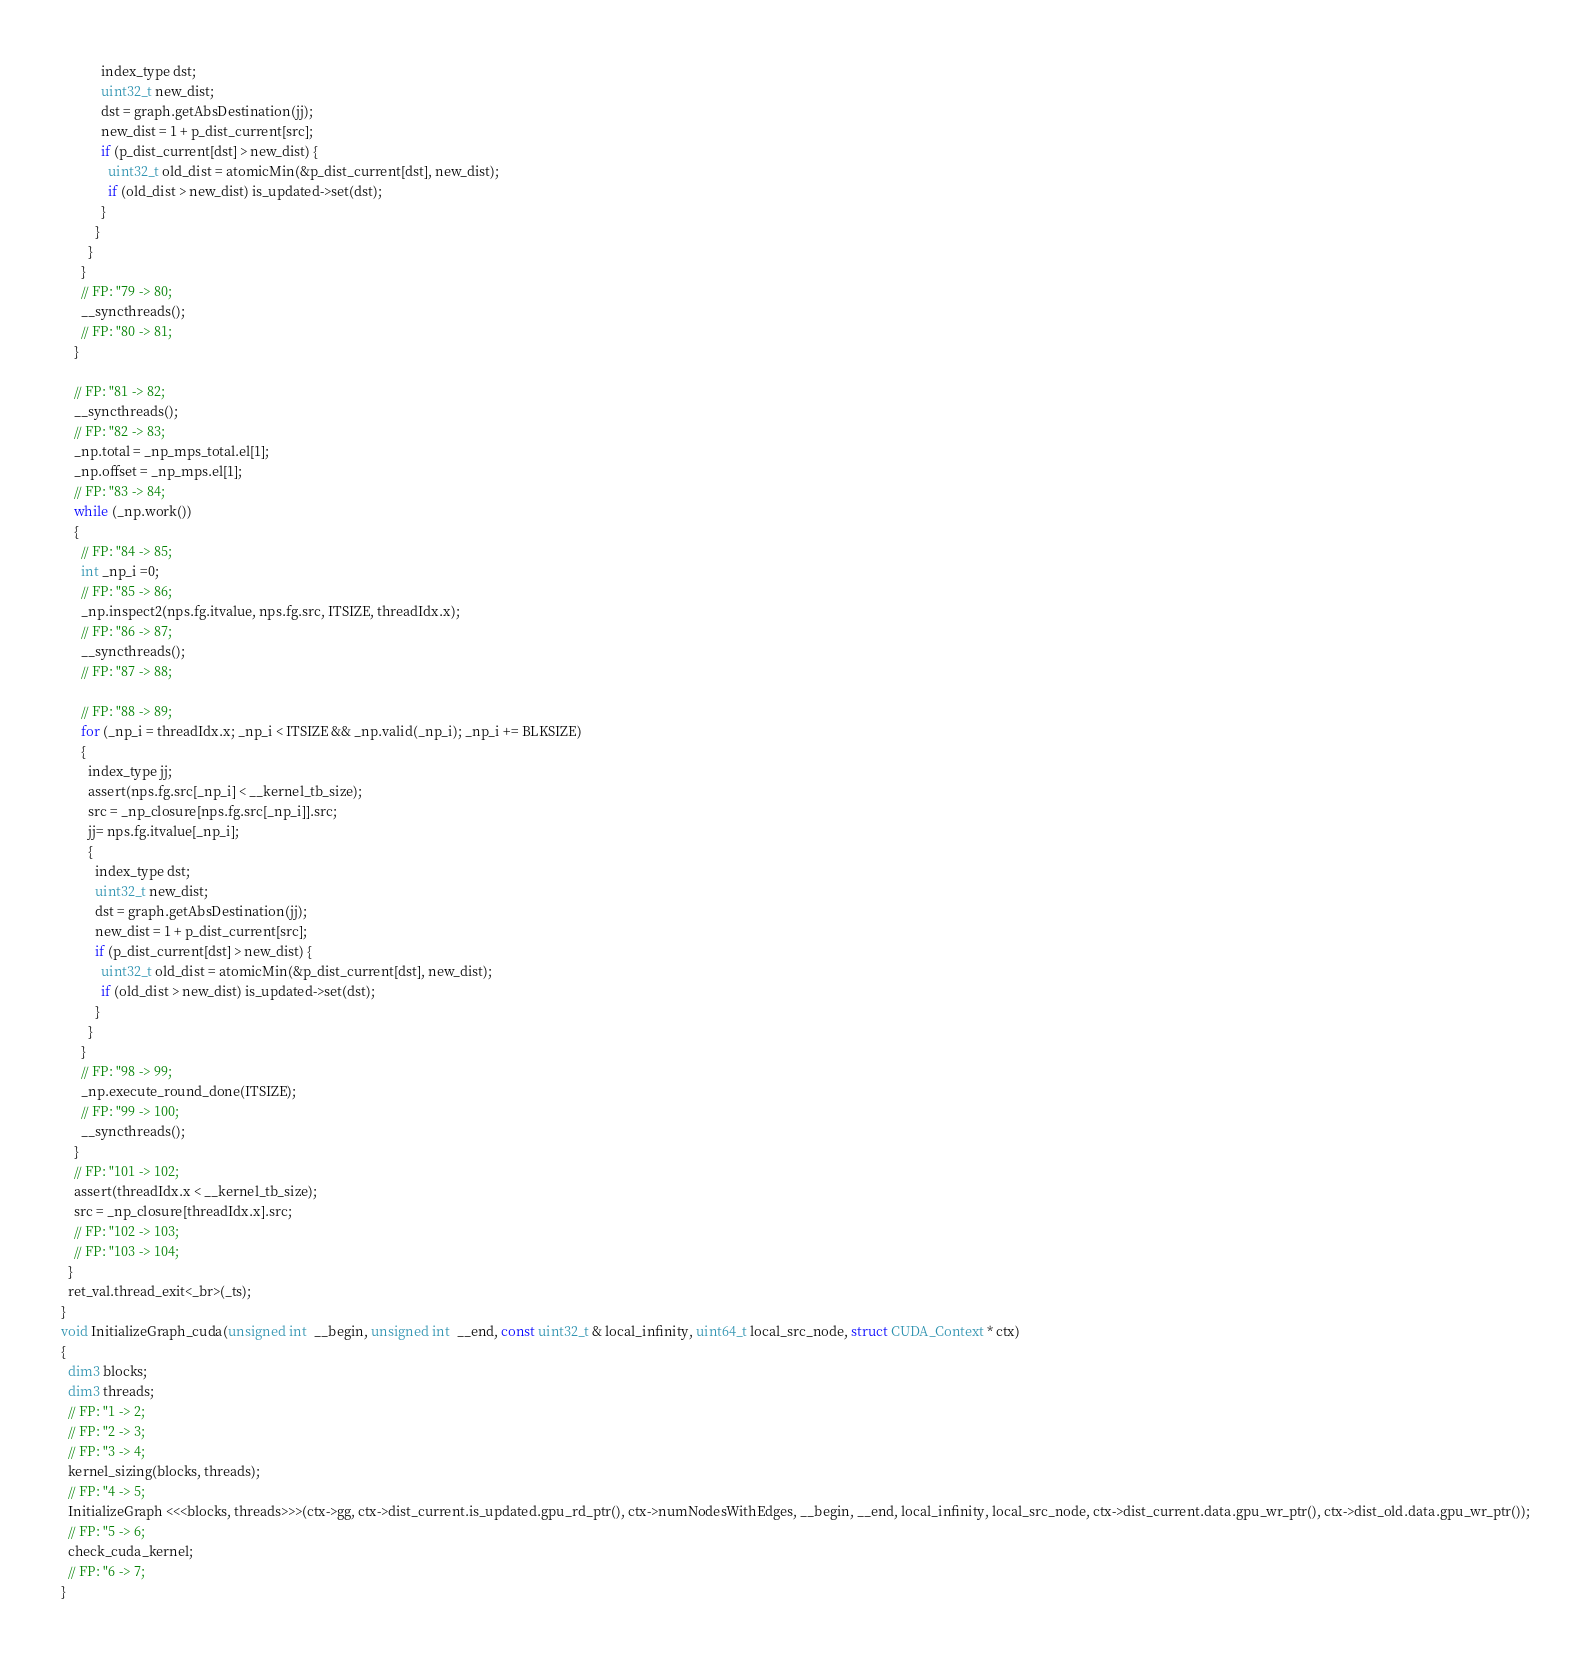Convert code to text. <code><loc_0><loc_0><loc_500><loc_500><_Cuda_>            index_type dst;
            uint32_t new_dist;
            dst = graph.getAbsDestination(jj);
            new_dist = 1 + p_dist_current[src];
            if (p_dist_current[dst] > new_dist) {
              uint32_t old_dist = atomicMin(&p_dist_current[dst], new_dist);
              if (old_dist > new_dist) is_updated->set(dst);
            }
          }
        }
      }
      // FP: "79 -> 80;
      __syncthreads();
      // FP: "80 -> 81;
    }

    // FP: "81 -> 82;
    __syncthreads();
    // FP: "82 -> 83;
    _np.total = _np_mps_total.el[1];
    _np.offset = _np_mps.el[1];
    // FP: "83 -> 84;
    while (_np.work())
    {
      // FP: "84 -> 85;
      int _np_i =0;
      // FP: "85 -> 86;
      _np.inspect2(nps.fg.itvalue, nps.fg.src, ITSIZE, threadIdx.x);
      // FP: "86 -> 87;
      __syncthreads();
      // FP: "87 -> 88;

      // FP: "88 -> 89;
      for (_np_i = threadIdx.x; _np_i < ITSIZE && _np.valid(_np_i); _np_i += BLKSIZE)
      {
        index_type jj;
        assert(nps.fg.src[_np_i] < __kernel_tb_size);
        src = _np_closure[nps.fg.src[_np_i]].src;
        jj= nps.fg.itvalue[_np_i];
        {
          index_type dst;
          uint32_t new_dist;
          dst = graph.getAbsDestination(jj);
          new_dist = 1 + p_dist_current[src];
          if (p_dist_current[dst] > new_dist) {
            uint32_t old_dist = atomicMin(&p_dist_current[dst], new_dist);
            if (old_dist > new_dist) is_updated->set(dst);
          }
        }
      }
      // FP: "98 -> 99;
      _np.execute_round_done(ITSIZE);
      // FP: "99 -> 100;
      __syncthreads();
    }
    // FP: "101 -> 102;
    assert(threadIdx.x < __kernel_tb_size);
    src = _np_closure[threadIdx.x].src;
    // FP: "102 -> 103;
    // FP: "103 -> 104;
  }
  ret_val.thread_exit<_br>(_ts);
}
void InitializeGraph_cuda(unsigned int  __begin, unsigned int  __end, const uint32_t & local_infinity, uint64_t local_src_node, struct CUDA_Context * ctx)
{
  dim3 blocks;
  dim3 threads;
  // FP: "1 -> 2;
  // FP: "2 -> 3;
  // FP: "3 -> 4;
  kernel_sizing(blocks, threads);
  // FP: "4 -> 5;
  InitializeGraph <<<blocks, threads>>>(ctx->gg, ctx->dist_current.is_updated.gpu_rd_ptr(), ctx->numNodesWithEdges, __begin, __end, local_infinity, local_src_node, ctx->dist_current.data.gpu_wr_ptr(), ctx->dist_old.data.gpu_wr_ptr());
  // FP: "5 -> 6;
  check_cuda_kernel;
  // FP: "6 -> 7;
}</code> 